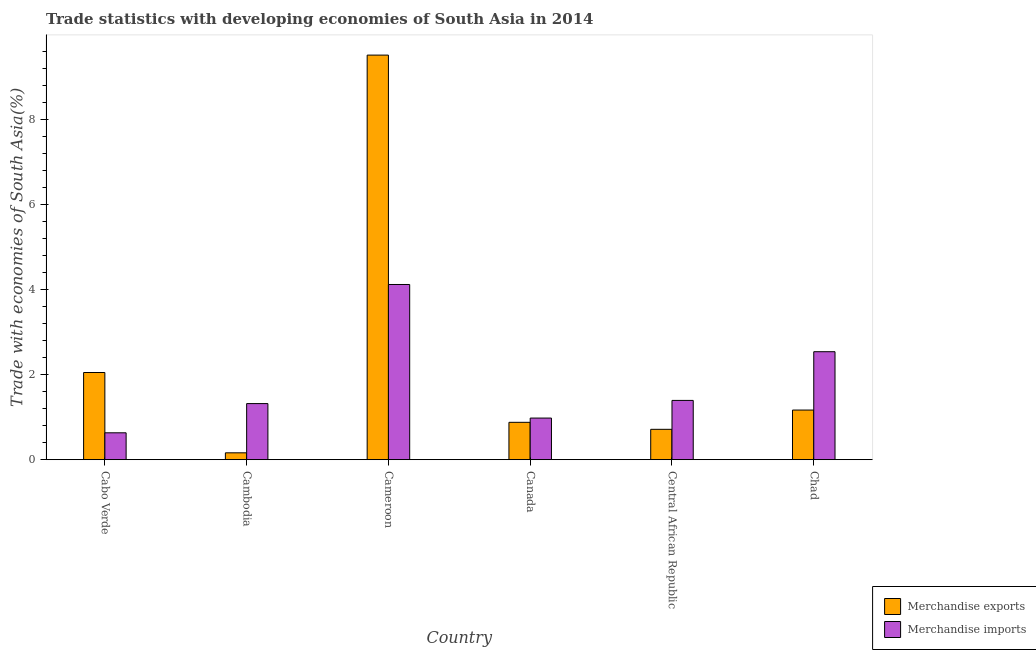How many groups of bars are there?
Offer a terse response. 6. Are the number of bars per tick equal to the number of legend labels?
Your answer should be very brief. Yes. Are the number of bars on each tick of the X-axis equal?
Your answer should be very brief. Yes. What is the label of the 4th group of bars from the left?
Your response must be concise. Canada. What is the merchandise exports in Chad?
Ensure brevity in your answer.  1.17. Across all countries, what is the maximum merchandise exports?
Offer a terse response. 9.51. Across all countries, what is the minimum merchandise exports?
Make the answer very short. 0.16. In which country was the merchandise imports maximum?
Keep it short and to the point. Cameroon. In which country was the merchandise imports minimum?
Give a very brief answer. Cabo Verde. What is the total merchandise exports in the graph?
Provide a succinct answer. 14.48. What is the difference between the merchandise exports in Cameroon and that in Chad?
Provide a short and direct response. 8.34. What is the difference between the merchandise imports in Cambodia and the merchandise exports in Cameroon?
Offer a terse response. -8.19. What is the average merchandise exports per country?
Your response must be concise. 2.41. What is the difference between the merchandise imports and merchandise exports in Chad?
Offer a terse response. 1.37. In how many countries, is the merchandise exports greater than 4.4 %?
Provide a short and direct response. 1. What is the ratio of the merchandise imports in Cabo Verde to that in Cameroon?
Offer a terse response. 0.15. What is the difference between the highest and the second highest merchandise exports?
Your response must be concise. 7.46. What is the difference between the highest and the lowest merchandise imports?
Make the answer very short. 3.49. Is the sum of the merchandise exports in Cambodia and Cameroon greater than the maximum merchandise imports across all countries?
Your answer should be very brief. Yes. What does the 2nd bar from the left in Cambodia represents?
Offer a very short reply. Merchandise imports. What does the 1st bar from the right in Central African Republic represents?
Your response must be concise. Merchandise imports. How many bars are there?
Keep it short and to the point. 12. Does the graph contain any zero values?
Your response must be concise. No. Where does the legend appear in the graph?
Give a very brief answer. Bottom right. How many legend labels are there?
Provide a short and direct response. 2. How are the legend labels stacked?
Offer a terse response. Vertical. What is the title of the graph?
Ensure brevity in your answer.  Trade statistics with developing economies of South Asia in 2014. Does "Total Population" appear as one of the legend labels in the graph?
Provide a succinct answer. No. What is the label or title of the X-axis?
Keep it short and to the point. Country. What is the label or title of the Y-axis?
Ensure brevity in your answer.  Trade with economies of South Asia(%). What is the Trade with economies of South Asia(%) of Merchandise exports in Cabo Verde?
Make the answer very short. 2.05. What is the Trade with economies of South Asia(%) in Merchandise imports in Cabo Verde?
Provide a short and direct response. 0.63. What is the Trade with economies of South Asia(%) in Merchandise exports in Cambodia?
Offer a terse response. 0.16. What is the Trade with economies of South Asia(%) of Merchandise imports in Cambodia?
Offer a very short reply. 1.32. What is the Trade with economies of South Asia(%) in Merchandise exports in Cameroon?
Provide a succinct answer. 9.51. What is the Trade with economies of South Asia(%) in Merchandise imports in Cameroon?
Keep it short and to the point. 4.12. What is the Trade with economies of South Asia(%) of Merchandise exports in Canada?
Provide a succinct answer. 0.88. What is the Trade with economies of South Asia(%) in Merchandise imports in Canada?
Offer a very short reply. 0.98. What is the Trade with economies of South Asia(%) in Merchandise exports in Central African Republic?
Give a very brief answer. 0.71. What is the Trade with economies of South Asia(%) in Merchandise imports in Central African Republic?
Keep it short and to the point. 1.39. What is the Trade with economies of South Asia(%) of Merchandise exports in Chad?
Ensure brevity in your answer.  1.17. What is the Trade with economies of South Asia(%) of Merchandise imports in Chad?
Your answer should be compact. 2.54. Across all countries, what is the maximum Trade with economies of South Asia(%) in Merchandise exports?
Give a very brief answer. 9.51. Across all countries, what is the maximum Trade with economies of South Asia(%) of Merchandise imports?
Your answer should be compact. 4.12. Across all countries, what is the minimum Trade with economies of South Asia(%) of Merchandise exports?
Provide a succinct answer. 0.16. Across all countries, what is the minimum Trade with economies of South Asia(%) of Merchandise imports?
Offer a very short reply. 0.63. What is the total Trade with economies of South Asia(%) of Merchandise exports in the graph?
Your answer should be compact. 14.48. What is the total Trade with economies of South Asia(%) in Merchandise imports in the graph?
Offer a terse response. 10.98. What is the difference between the Trade with economies of South Asia(%) of Merchandise exports in Cabo Verde and that in Cambodia?
Your response must be concise. 1.89. What is the difference between the Trade with economies of South Asia(%) of Merchandise imports in Cabo Verde and that in Cambodia?
Offer a terse response. -0.69. What is the difference between the Trade with economies of South Asia(%) in Merchandise exports in Cabo Verde and that in Cameroon?
Provide a succinct answer. -7.46. What is the difference between the Trade with economies of South Asia(%) in Merchandise imports in Cabo Verde and that in Cameroon?
Ensure brevity in your answer.  -3.49. What is the difference between the Trade with economies of South Asia(%) of Merchandise exports in Cabo Verde and that in Canada?
Offer a very short reply. 1.17. What is the difference between the Trade with economies of South Asia(%) in Merchandise imports in Cabo Verde and that in Canada?
Provide a short and direct response. -0.35. What is the difference between the Trade with economies of South Asia(%) in Merchandise exports in Cabo Verde and that in Central African Republic?
Offer a terse response. 1.33. What is the difference between the Trade with economies of South Asia(%) of Merchandise imports in Cabo Verde and that in Central African Republic?
Provide a short and direct response. -0.76. What is the difference between the Trade with economies of South Asia(%) of Merchandise exports in Cabo Verde and that in Chad?
Keep it short and to the point. 0.88. What is the difference between the Trade with economies of South Asia(%) in Merchandise imports in Cabo Verde and that in Chad?
Offer a very short reply. -1.91. What is the difference between the Trade with economies of South Asia(%) of Merchandise exports in Cambodia and that in Cameroon?
Your answer should be very brief. -9.35. What is the difference between the Trade with economies of South Asia(%) of Merchandise imports in Cambodia and that in Cameroon?
Your response must be concise. -2.8. What is the difference between the Trade with economies of South Asia(%) of Merchandise exports in Cambodia and that in Canada?
Your response must be concise. -0.72. What is the difference between the Trade with economies of South Asia(%) in Merchandise imports in Cambodia and that in Canada?
Make the answer very short. 0.34. What is the difference between the Trade with economies of South Asia(%) of Merchandise exports in Cambodia and that in Central African Republic?
Your response must be concise. -0.55. What is the difference between the Trade with economies of South Asia(%) in Merchandise imports in Cambodia and that in Central African Republic?
Offer a very short reply. -0.07. What is the difference between the Trade with economies of South Asia(%) in Merchandise exports in Cambodia and that in Chad?
Ensure brevity in your answer.  -1. What is the difference between the Trade with economies of South Asia(%) in Merchandise imports in Cambodia and that in Chad?
Give a very brief answer. -1.22. What is the difference between the Trade with economies of South Asia(%) in Merchandise exports in Cameroon and that in Canada?
Provide a short and direct response. 8.63. What is the difference between the Trade with economies of South Asia(%) in Merchandise imports in Cameroon and that in Canada?
Give a very brief answer. 3.14. What is the difference between the Trade with economies of South Asia(%) in Merchandise exports in Cameroon and that in Central African Republic?
Offer a very short reply. 8.8. What is the difference between the Trade with economies of South Asia(%) in Merchandise imports in Cameroon and that in Central African Republic?
Offer a terse response. 2.72. What is the difference between the Trade with economies of South Asia(%) of Merchandise exports in Cameroon and that in Chad?
Your answer should be compact. 8.34. What is the difference between the Trade with economies of South Asia(%) of Merchandise imports in Cameroon and that in Chad?
Provide a short and direct response. 1.58. What is the difference between the Trade with economies of South Asia(%) of Merchandise exports in Canada and that in Central African Republic?
Provide a succinct answer. 0.16. What is the difference between the Trade with economies of South Asia(%) in Merchandise imports in Canada and that in Central African Republic?
Your answer should be very brief. -0.42. What is the difference between the Trade with economies of South Asia(%) in Merchandise exports in Canada and that in Chad?
Provide a succinct answer. -0.29. What is the difference between the Trade with economies of South Asia(%) in Merchandise imports in Canada and that in Chad?
Offer a terse response. -1.56. What is the difference between the Trade with economies of South Asia(%) of Merchandise exports in Central African Republic and that in Chad?
Your answer should be compact. -0.45. What is the difference between the Trade with economies of South Asia(%) of Merchandise imports in Central African Republic and that in Chad?
Make the answer very short. -1.14. What is the difference between the Trade with economies of South Asia(%) in Merchandise exports in Cabo Verde and the Trade with economies of South Asia(%) in Merchandise imports in Cambodia?
Offer a terse response. 0.73. What is the difference between the Trade with economies of South Asia(%) in Merchandise exports in Cabo Verde and the Trade with economies of South Asia(%) in Merchandise imports in Cameroon?
Offer a terse response. -2.07. What is the difference between the Trade with economies of South Asia(%) of Merchandise exports in Cabo Verde and the Trade with economies of South Asia(%) of Merchandise imports in Canada?
Make the answer very short. 1.07. What is the difference between the Trade with economies of South Asia(%) of Merchandise exports in Cabo Verde and the Trade with economies of South Asia(%) of Merchandise imports in Central African Republic?
Ensure brevity in your answer.  0.66. What is the difference between the Trade with economies of South Asia(%) in Merchandise exports in Cabo Verde and the Trade with economies of South Asia(%) in Merchandise imports in Chad?
Offer a very short reply. -0.49. What is the difference between the Trade with economies of South Asia(%) in Merchandise exports in Cambodia and the Trade with economies of South Asia(%) in Merchandise imports in Cameroon?
Your answer should be very brief. -3.96. What is the difference between the Trade with economies of South Asia(%) in Merchandise exports in Cambodia and the Trade with economies of South Asia(%) in Merchandise imports in Canada?
Keep it short and to the point. -0.82. What is the difference between the Trade with economies of South Asia(%) in Merchandise exports in Cambodia and the Trade with economies of South Asia(%) in Merchandise imports in Central African Republic?
Give a very brief answer. -1.23. What is the difference between the Trade with economies of South Asia(%) of Merchandise exports in Cambodia and the Trade with economies of South Asia(%) of Merchandise imports in Chad?
Make the answer very short. -2.38. What is the difference between the Trade with economies of South Asia(%) in Merchandise exports in Cameroon and the Trade with economies of South Asia(%) in Merchandise imports in Canada?
Your answer should be compact. 8.53. What is the difference between the Trade with economies of South Asia(%) of Merchandise exports in Cameroon and the Trade with economies of South Asia(%) of Merchandise imports in Central African Republic?
Your response must be concise. 8.12. What is the difference between the Trade with economies of South Asia(%) in Merchandise exports in Cameroon and the Trade with economies of South Asia(%) in Merchandise imports in Chad?
Your response must be concise. 6.97. What is the difference between the Trade with economies of South Asia(%) in Merchandise exports in Canada and the Trade with economies of South Asia(%) in Merchandise imports in Central African Republic?
Keep it short and to the point. -0.51. What is the difference between the Trade with economies of South Asia(%) of Merchandise exports in Canada and the Trade with economies of South Asia(%) of Merchandise imports in Chad?
Offer a very short reply. -1.66. What is the difference between the Trade with economies of South Asia(%) of Merchandise exports in Central African Republic and the Trade with economies of South Asia(%) of Merchandise imports in Chad?
Ensure brevity in your answer.  -1.82. What is the average Trade with economies of South Asia(%) of Merchandise exports per country?
Offer a terse response. 2.41. What is the average Trade with economies of South Asia(%) in Merchandise imports per country?
Provide a succinct answer. 1.83. What is the difference between the Trade with economies of South Asia(%) in Merchandise exports and Trade with economies of South Asia(%) in Merchandise imports in Cabo Verde?
Provide a short and direct response. 1.42. What is the difference between the Trade with economies of South Asia(%) of Merchandise exports and Trade with economies of South Asia(%) of Merchandise imports in Cambodia?
Provide a short and direct response. -1.16. What is the difference between the Trade with economies of South Asia(%) of Merchandise exports and Trade with economies of South Asia(%) of Merchandise imports in Cameroon?
Give a very brief answer. 5.39. What is the difference between the Trade with economies of South Asia(%) of Merchandise exports and Trade with economies of South Asia(%) of Merchandise imports in Canada?
Ensure brevity in your answer.  -0.1. What is the difference between the Trade with economies of South Asia(%) in Merchandise exports and Trade with economies of South Asia(%) in Merchandise imports in Central African Republic?
Keep it short and to the point. -0.68. What is the difference between the Trade with economies of South Asia(%) of Merchandise exports and Trade with economies of South Asia(%) of Merchandise imports in Chad?
Offer a terse response. -1.37. What is the ratio of the Trade with economies of South Asia(%) of Merchandise exports in Cabo Verde to that in Cambodia?
Your response must be concise. 12.67. What is the ratio of the Trade with economies of South Asia(%) in Merchandise imports in Cabo Verde to that in Cambodia?
Offer a very short reply. 0.48. What is the ratio of the Trade with economies of South Asia(%) of Merchandise exports in Cabo Verde to that in Cameroon?
Your answer should be very brief. 0.22. What is the ratio of the Trade with economies of South Asia(%) in Merchandise imports in Cabo Verde to that in Cameroon?
Ensure brevity in your answer.  0.15. What is the ratio of the Trade with economies of South Asia(%) in Merchandise exports in Cabo Verde to that in Canada?
Give a very brief answer. 2.33. What is the ratio of the Trade with economies of South Asia(%) in Merchandise imports in Cabo Verde to that in Canada?
Keep it short and to the point. 0.65. What is the ratio of the Trade with economies of South Asia(%) of Merchandise exports in Cabo Verde to that in Central African Republic?
Offer a terse response. 2.87. What is the ratio of the Trade with economies of South Asia(%) in Merchandise imports in Cabo Verde to that in Central African Republic?
Offer a very short reply. 0.45. What is the ratio of the Trade with economies of South Asia(%) in Merchandise exports in Cabo Verde to that in Chad?
Make the answer very short. 1.76. What is the ratio of the Trade with economies of South Asia(%) in Merchandise imports in Cabo Verde to that in Chad?
Offer a very short reply. 0.25. What is the ratio of the Trade with economies of South Asia(%) of Merchandise exports in Cambodia to that in Cameroon?
Provide a short and direct response. 0.02. What is the ratio of the Trade with economies of South Asia(%) in Merchandise imports in Cambodia to that in Cameroon?
Give a very brief answer. 0.32. What is the ratio of the Trade with economies of South Asia(%) in Merchandise exports in Cambodia to that in Canada?
Make the answer very short. 0.18. What is the ratio of the Trade with economies of South Asia(%) in Merchandise imports in Cambodia to that in Canada?
Ensure brevity in your answer.  1.35. What is the ratio of the Trade with economies of South Asia(%) of Merchandise exports in Cambodia to that in Central African Republic?
Offer a terse response. 0.23. What is the ratio of the Trade with economies of South Asia(%) of Merchandise imports in Cambodia to that in Central African Republic?
Your answer should be very brief. 0.95. What is the ratio of the Trade with economies of South Asia(%) in Merchandise exports in Cambodia to that in Chad?
Your answer should be compact. 0.14. What is the ratio of the Trade with economies of South Asia(%) in Merchandise imports in Cambodia to that in Chad?
Your response must be concise. 0.52. What is the ratio of the Trade with economies of South Asia(%) of Merchandise exports in Cameroon to that in Canada?
Keep it short and to the point. 10.82. What is the ratio of the Trade with economies of South Asia(%) of Merchandise imports in Cameroon to that in Canada?
Your answer should be very brief. 4.21. What is the ratio of the Trade with economies of South Asia(%) in Merchandise exports in Cameroon to that in Central African Republic?
Keep it short and to the point. 13.32. What is the ratio of the Trade with economies of South Asia(%) of Merchandise imports in Cameroon to that in Central African Republic?
Offer a terse response. 2.96. What is the ratio of the Trade with economies of South Asia(%) of Merchandise exports in Cameroon to that in Chad?
Ensure brevity in your answer.  8.15. What is the ratio of the Trade with economies of South Asia(%) of Merchandise imports in Cameroon to that in Chad?
Provide a short and direct response. 1.62. What is the ratio of the Trade with economies of South Asia(%) in Merchandise exports in Canada to that in Central African Republic?
Ensure brevity in your answer.  1.23. What is the ratio of the Trade with economies of South Asia(%) of Merchandise imports in Canada to that in Central African Republic?
Ensure brevity in your answer.  0.7. What is the ratio of the Trade with economies of South Asia(%) in Merchandise exports in Canada to that in Chad?
Provide a short and direct response. 0.75. What is the ratio of the Trade with economies of South Asia(%) of Merchandise imports in Canada to that in Chad?
Keep it short and to the point. 0.39. What is the ratio of the Trade with economies of South Asia(%) of Merchandise exports in Central African Republic to that in Chad?
Your answer should be very brief. 0.61. What is the ratio of the Trade with economies of South Asia(%) in Merchandise imports in Central African Republic to that in Chad?
Your answer should be compact. 0.55. What is the difference between the highest and the second highest Trade with economies of South Asia(%) in Merchandise exports?
Provide a succinct answer. 7.46. What is the difference between the highest and the second highest Trade with economies of South Asia(%) in Merchandise imports?
Provide a succinct answer. 1.58. What is the difference between the highest and the lowest Trade with economies of South Asia(%) of Merchandise exports?
Ensure brevity in your answer.  9.35. What is the difference between the highest and the lowest Trade with economies of South Asia(%) in Merchandise imports?
Your answer should be very brief. 3.49. 